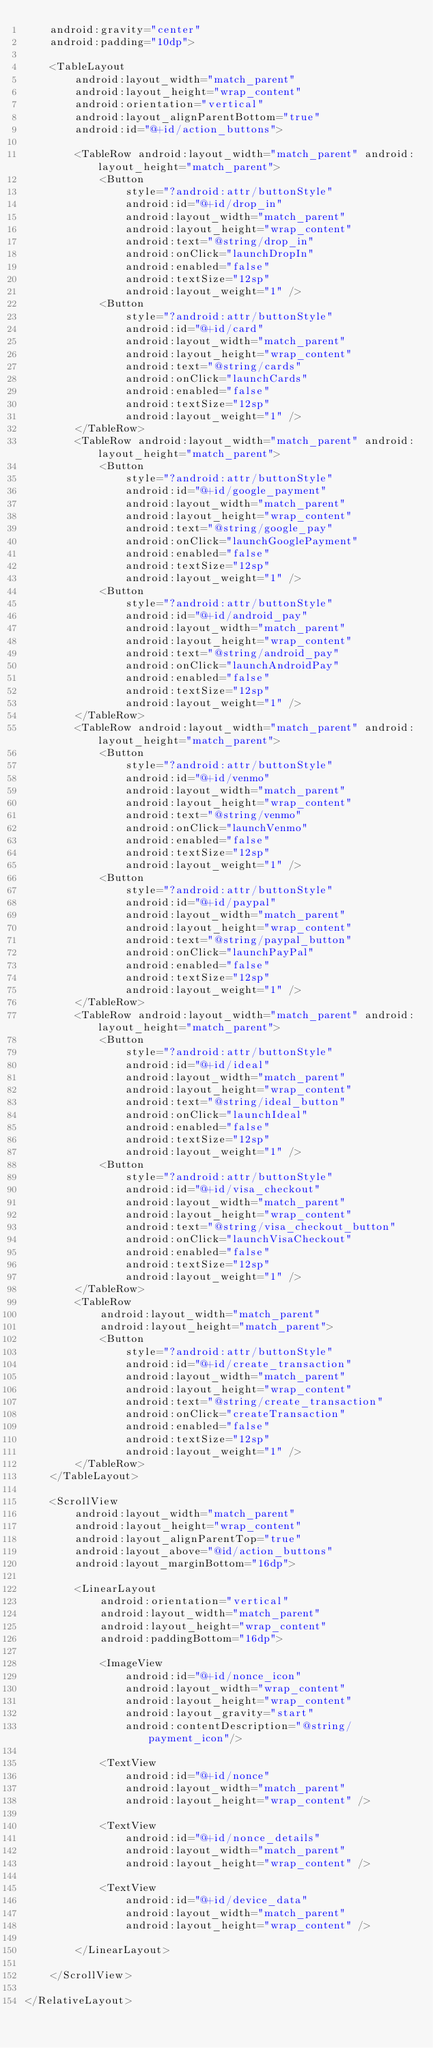<code> <loc_0><loc_0><loc_500><loc_500><_XML_>    android:gravity="center"
    android:padding="10dp">

    <TableLayout
        android:layout_width="match_parent"
        android:layout_height="wrap_content"
        android:orientation="vertical"
        android:layout_alignParentBottom="true"
        android:id="@+id/action_buttons">

        <TableRow android:layout_width="match_parent" android:layout_height="match_parent">
            <Button
                style="?android:attr/buttonStyle"
                android:id="@+id/drop_in"
                android:layout_width="match_parent"
                android:layout_height="wrap_content"
                android:text="@string/drop_in"
                android:onClick="launchDropIn"
                android:enabled="false"
                android:textSize="12sp"
                android:layout_weight="1" />
            <Button
                style="?android:attr/buttonStyle"
                android:id="@+id/card"
                android:layout_width="match_parent"
                android:layout_height="wrap_content"
                android:text="@string/cards"
                android:onClick="launchCards"
                android:enabled="false"
                android:textSize="12sp"
                android:layout_weight="1" />
        </TableRow>
        <TableRow android:layout_width="match_parent" android:layout_height="match_parent">
            <Button
                style="?android:attr/buttonStyle"
                android:id="@+id/google_payment"
                android:layout_width="match_parent"
                android:layout_height="wrap_content"
                android:text="@string/google_pay"
                android:onClick="launchGooglePayment"
                android:enabled="false"
                android:textSize="12sp"
                android:layout_weight="1" />
            <Button
                style="?android:attr/buttonStyle"
                android:id="@+id/android_pay"
                android:layout_width="match_parent"
                android:layout_height="wrap_content"
                android:text="@string/android_pay"
                android:onClick="launchAndroidPay"
                android:enabled="false"
                android:textSize="12sp"
                android:layout_weight="1" />
        </TableRow>
        <TableRow android:layout_width="match_parent" android:layout_height="match_parent">
            <Button
                style="?android:attr/buttonStyle"
                android:id="@+id/venmo"
                android:layout_width="match_parent"
                android:layout_height="wrap_content"
                android:text="@string/venmo"
                android:onClick="launchVenmo"
                android:enabled="false"
                android:textSize="12sp"
                android:layout_weight="1" />
            <Button
                style="?android:attr/buttonStyle"
                android:id="@+id/paypal"
                android:layout_width="match_parent"
                android:layout_height="wrap_content"
                android:text="@string/paypal_button"
                android:onClick="launchPayPal"
                android:enabled="false"
                android:textSize="12sp"
                android:layout_weight="1" />
        </TableRow>
        <TableRow android:layout_width="match_parent" android:layout_height="match_parent">
            <Button
                style="?android:attr/buttonStyle"
                android:id="@+id/ideal"
                android:layout_width="match_parent"
                android:layout_height="wrap_content"
                android:text="@string/ideal_button"
                android:onClick="launchIdeal"
                android:enabled="false"
                android:textSize="12sp"
                android:layout_weight="1" />
            <Button
                style="?android:attr/buttonStyle"
                android:id="@+id/visa_checkout"
                android:layout_width="match_parent"
                android:layout_height="wrap_content"
                android:text="@string/visa_checkout_button"
                android:onClick="launchVisaCheckout"
                android:enabled="false"
                android:textSize="12sp"
                android:layout_weight="1" />
        </TableRow>
        <TableRow
            android:layout_width="match_parent"
            android:layout_height="match_parent">
            <Button
                style="?android:attr/buttonStyle"
                android:id="@+id/create_transaction"
                android:layout_width="match_parent"
                android:layout_height="wrap_content"
                android:text="@string/create_transaction"
                android:onClick="createTransaction"
                android:enabled="false"
                android:textSize="12sp"
                android:layout_weight="1" />
        </TableRow>
    </TableLayout>

    <ScrollView
        android:layout_width="match_parent"
        android:layout_height="wrap_content"
        android:layout_alignParentTop="true"
        android:layout_above="@id/action_buttons"
        android:layout_marginBottom="16dp">

        <LinearLayout
            android:orientation="vertical"
            android:layout_width="match_parent"
            android:layout_height="wrap_content"
            android:paddingBottom="16dp">

            <ImageView
                android:id="@+id/nonce_icon"
                android:layout_width="wrap_content"
                android:layout_height="wrap_content"
                android:layout_gravity="start"
                android:contentDescription="@string/payment_icon"/>

            <TextView
                android:id="@+id/nonce"
                android:layout_width="match_parent"
                android:layout_height="wrap_content" />

            <TextView
                android:id="@+id/nonce_details"
                android:layout_width="match_parent"
                android:layout_height="wrap_content" />

            <TextView
                android:id="@+id/device_data"
                android:layout_width="match_parent"
                android:layout_height="wrap_content" />

        </LinearLayout>

    </ScrollView>

</RelativeLayout>
</code> 